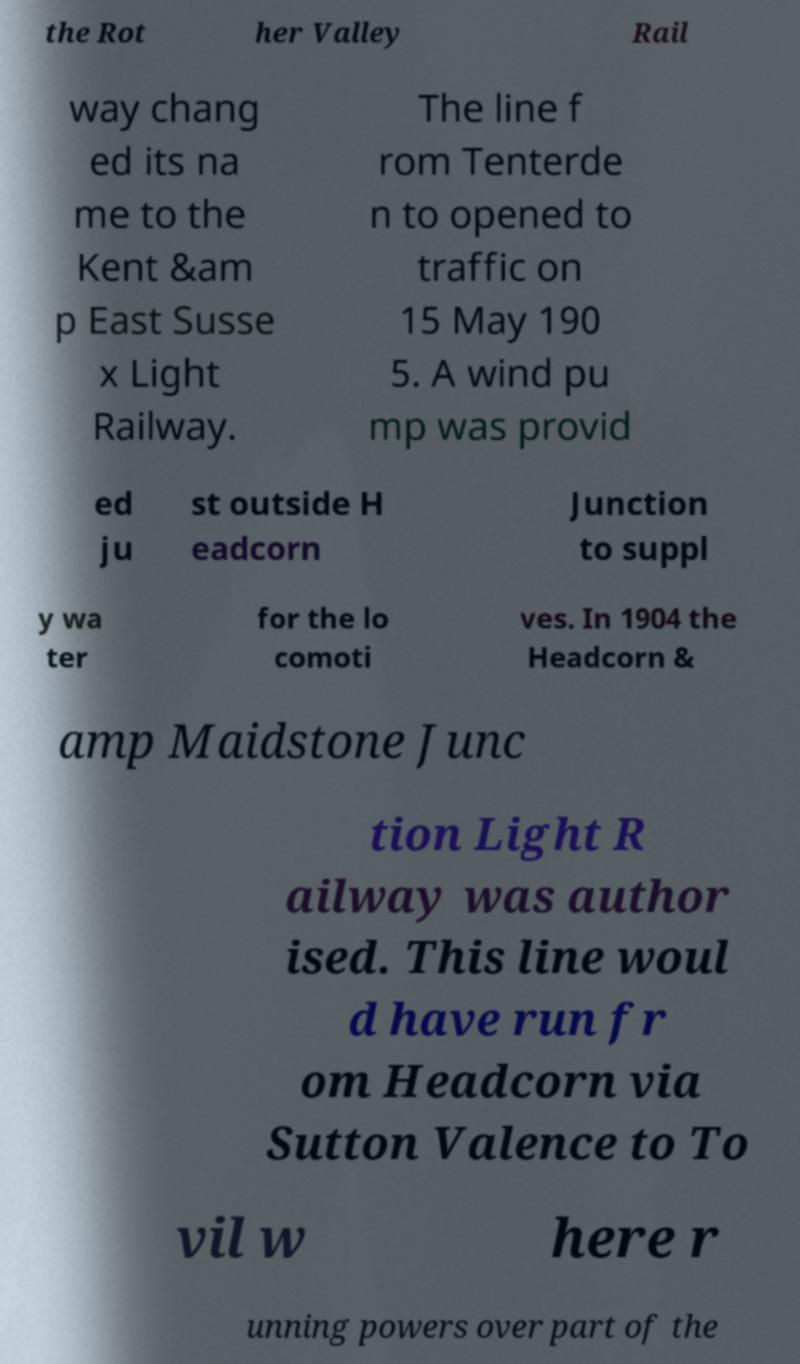I need the written content from this picture converted into text. Can you do that? the Rot her Valley Rail way chang ed its na me to the Kent &am p East Susse x Light Railway. The line f rom Tenterde n to opened to traffic on 15 May 190 5. A wind pu mp was provid ed ju st outside H eadcorn Junction to suppl y wa ter for the lo comoti ves. In 1904 the Headcorn & amp Maidstone Junc tion Light R ailway was author ised. This line woul d have run fr om Headcorn via Sutton Valence to To vil w here r unning powers over part of the 